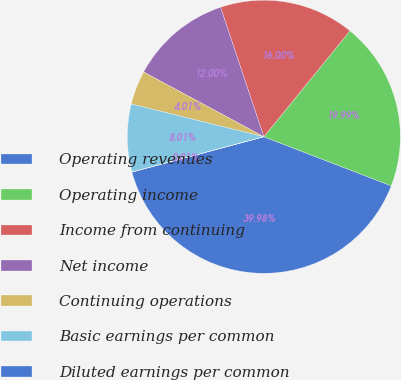Convert chart to OTSL. <chart><loc_0><loc_0><loc_500><loc_500><pie_chart><fcel>Operating revenues<fcel>Operating income<fcel>Income from continuing<fcel>Net income<fcel>Continuing operations<fcel>Basic earnings per common<fcel>Diluted earnings per common<nl><fcel>39.98%<fcel>19.99%<fcel>16.0%<fcel>12.0%<fcel>4.01%<fcel>8.01%<fcel>0.01%<nl></chart> 